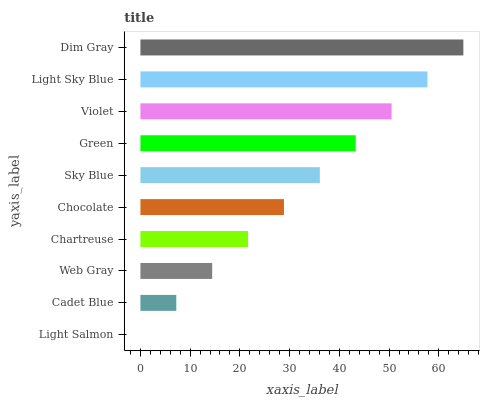Is Light Salmon the minimum?
Answer yes or no. Yes. Is Dim Gray the maximum?
Answer yes or no. Yes. Is Cadet Blue the minimum?
Answer yes or no. No. Is Cadet Blue the maximum?
Answer yes or no. No. Is Cadet Blue greater than Light Salmon?
Answer yes or no. Yes. Is Light Salmon less than Cadet Blue?
Answer yes or no. Yes. Is Light Salmon greater than Cadet Blue?
Answer yes or no. No. Is Cadet Blue less than Light Salmon?
Answer yes or no. No. Is Sky Blue the high median?
Answer yes or no. Yes. Is Chocolate the low median?
Answer yes or no. Yes. Is Web Gray the high median?
Answer yes or no. No. Is Chartreuse the low median?
Answer yes or no. No. 